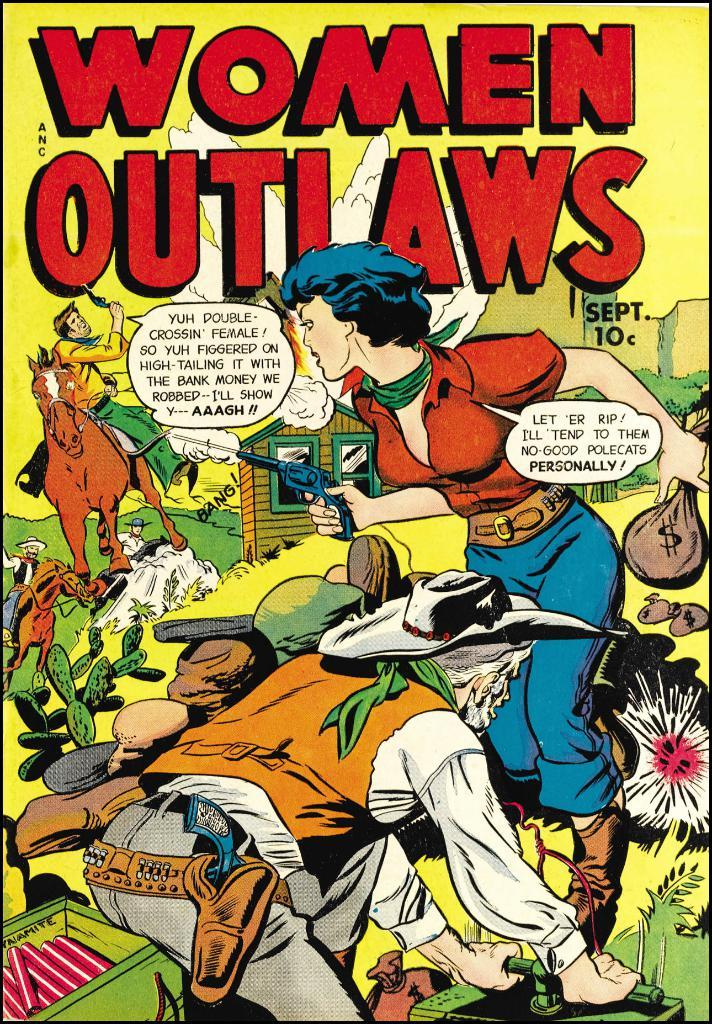<image>
Summarize the visual content of the image. A comic book shown is about women outlaws. 